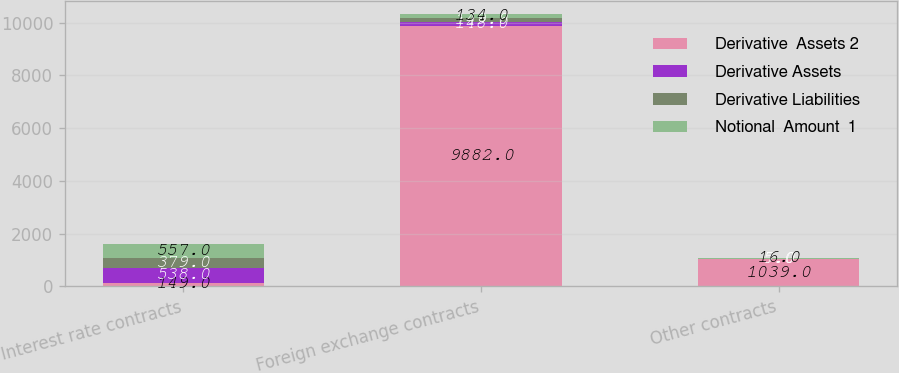Convert chart to OTSL. <chart><loc_0><loc_0><loc_500><loc_500><stacked_bar_chart><ecel><fcel>Interest rate contracts<fcel>Foreign exchange contracts<fcel>Other contracts<nl><fcel>Derivative  Assets 2<fcel>149<fcel>9882<fcel>1039<nl><fcel>Derivative Assets<fcel>538<fcel>148<fcel>7<nl><fcel>Derivative Liabilities<fcel>379<fcel>149<fcel>5<nl><fcel>Notional  Amount  1<fcel>557<fcel>134<fcel>16<nl></chart> 